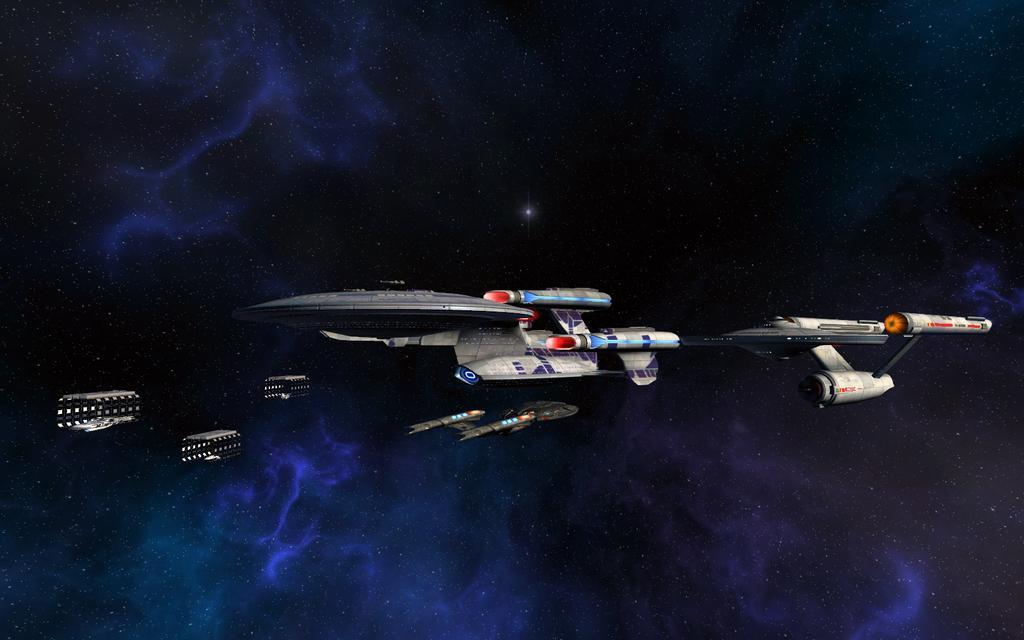Describe this image in one or two sentences. In this picture I can see spaceships in the sky. 